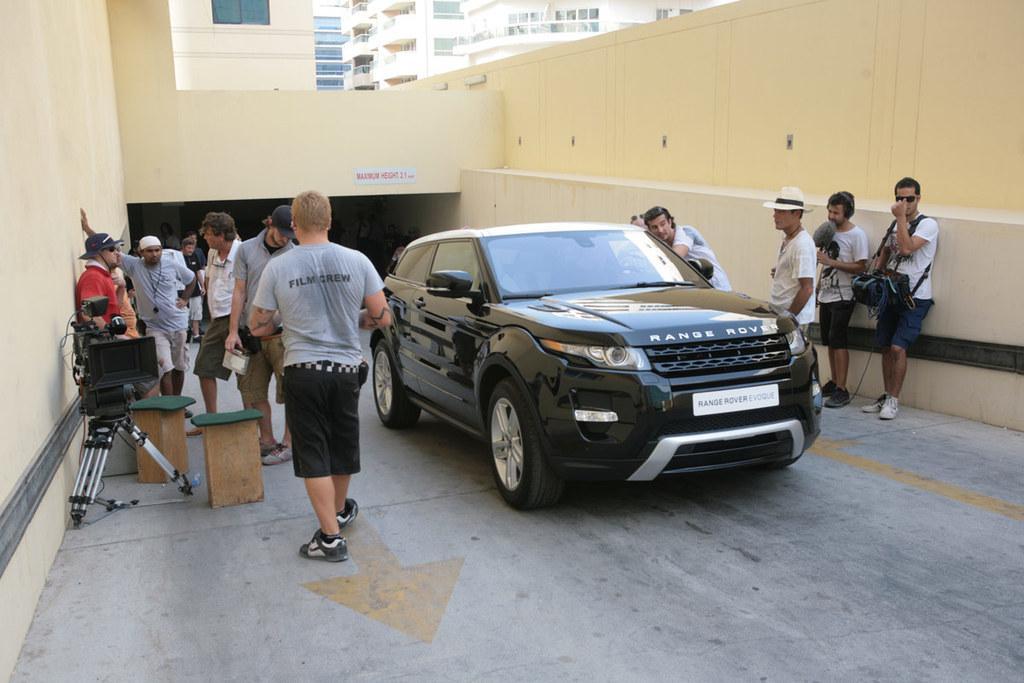Could you give a brief overview of what you see in this image? In the picture I can see people on the road and some are holding objects in hands. I can also see a black color vehicle, cameras and some other objects on the road. In the background I can see walls and buildings. 